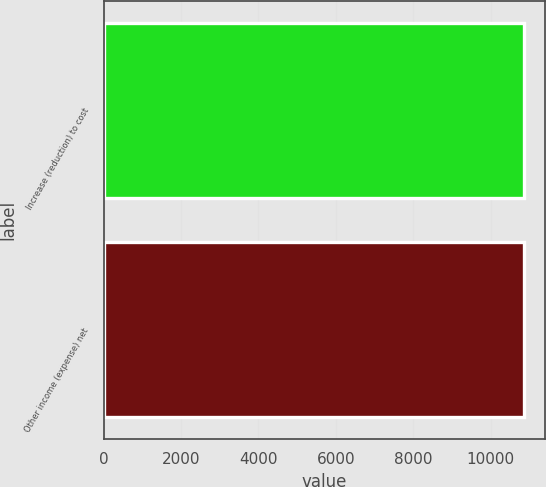Convert chart to OTSL. <chart><loc_0><loc_0><loc_500><loc_500><bar_chart><fcel>Increase (reduction) to cost<fcel>Other income (expense) net<nl><fcel>10856<fcel>10856.1<nl></chart> 